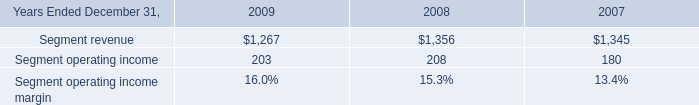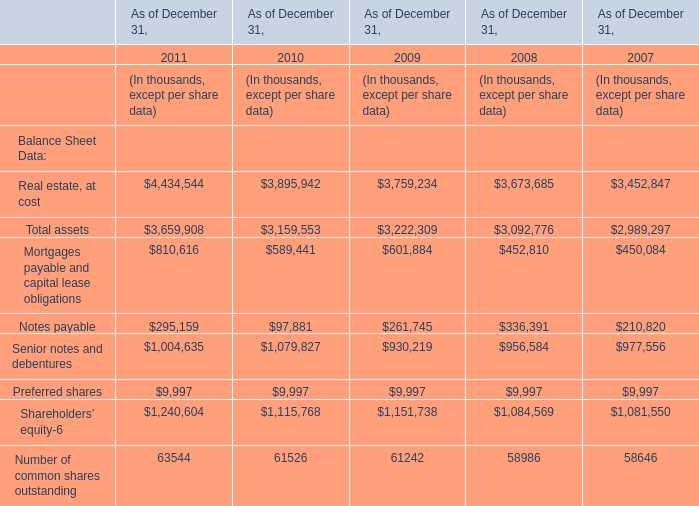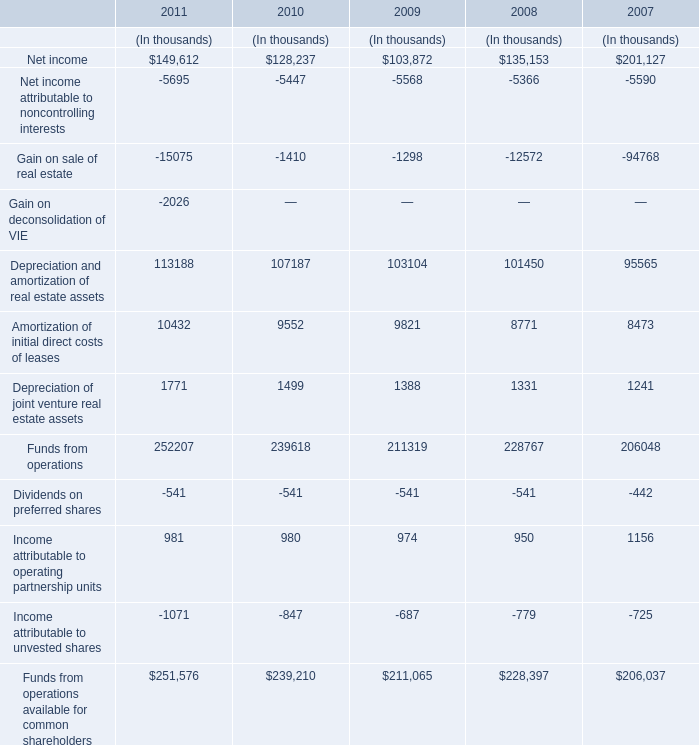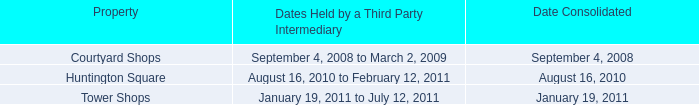In the year with lowest amount of Net income, what's the increasing rate of Funds from operations? (in %) 
Computations: ((211319 - 228767) / 228767)
Answer: -0.07627. 